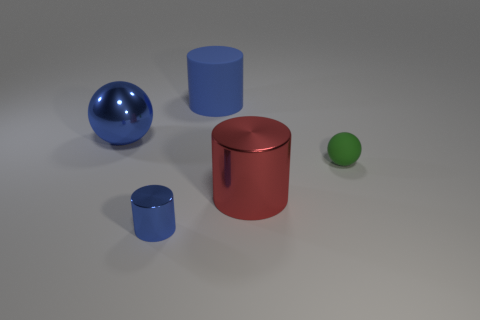What is the cylinder that is both behind the small blue metallic cylinder and left of the red cylinder made of?
Your answer should be very brief. Rubber. What number of other objects are there of the same material as the small blue cylinder?
Provide a succinct answer. 2. How many large matte cylinders are the same color as the big shiny sphere?
Keep it short and to the point. 1. What is the size of the ball on the right side of the blue metallic thing that is in front of the blue object to the left of the blue metallic cylinder?
Keep it short and to the point. Small. How many rubber things are tiny spheres or blue cylinders?
Your response must be concise. 2. Does the tiny green thing have the same shape as the large thing on the left side of the blue matte thing?
Ensure brevity in your answer.  Yes. Are there more tiny spheres that are in front of the large blue rubber object than small blue shiny things right of the big shiny cylinder?
Provide a short and direct response. Yes. Is there anything else that has the same color as the large metallic cylinder?
Provide a short and direct response. No. Are there any large red cylinders that are behind the shiny cylinder that is left of the large blue object behind the blue metallic ball?
Keep it short and to the point. Yes. Is the shape of the large metal object in front of the green thing the same as  the tiny blue shiny thing?
Offer a terse response. Yes. 